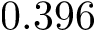Convert formula to latex. <formula><loc_0><loc_0><loc_500><loc_500>0 . 3 9 6</formula> 